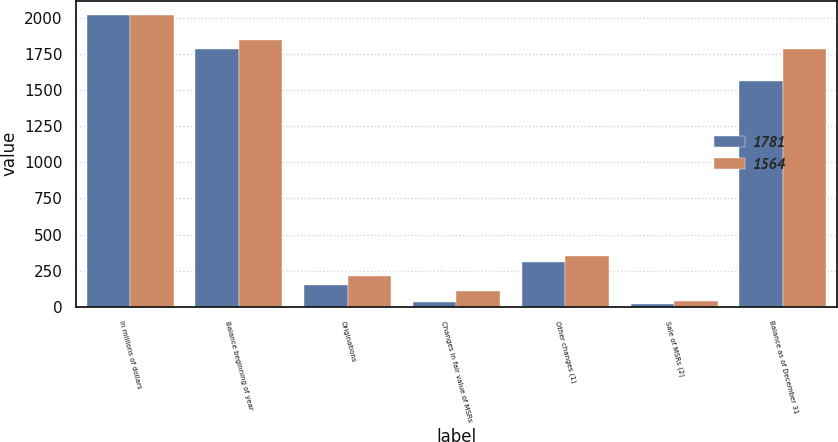Convert chart to OTSL. <chart><loc_0><loc_0><loc_500><loc_500><stacked_bar_chart><ecel><fcel>In millions of dollars<fcel>Balance beginning of year<fcel>Originations<fcel>Changes in fair value of MSRs<fcel>Other changes (1)<fcel>Sale of MSRs (2)<fcel>Balance as of December 31<nl><fcel>1781<fcel>2016<fcel>1781<fcel>152<fcel>36<fcel>313<fcel>20<fcel>1564<nl><fcel>1564<fcel>2015<fcel>1845<fcel>214<fcel>110<fcel>350<fcel>38<fcel>1781<nl></chart> 